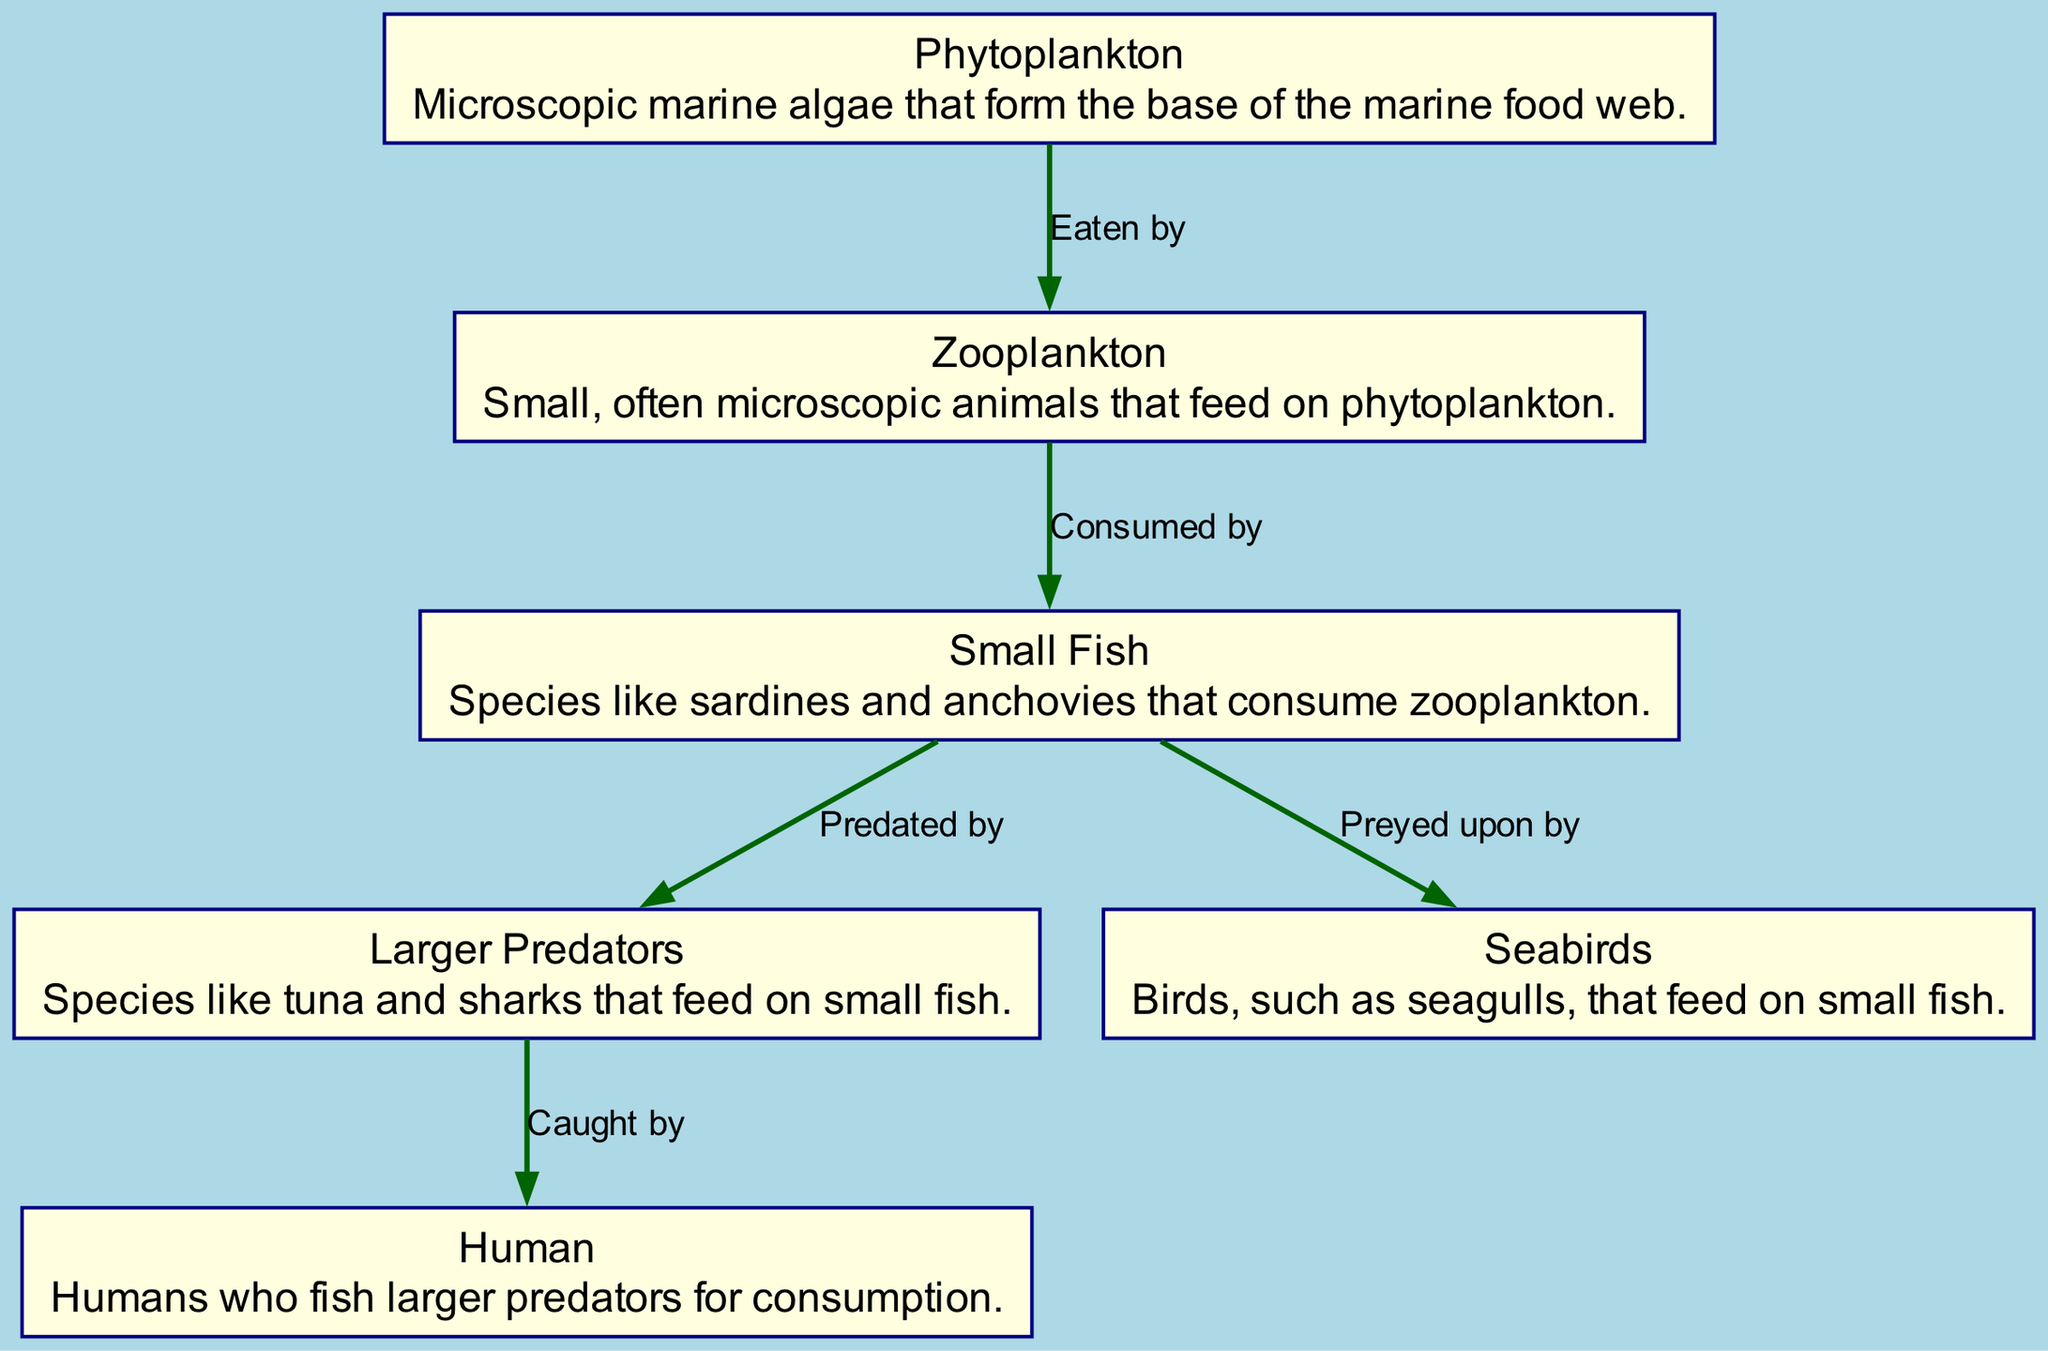What is the base of the marine food web? The diagram indicates that Phytoplankton forms the base of the marine food web, as it is the first node in the flow and is consumed by Zooplankton.
Answer: Phytoplankton How many nodes are present in the diagram? By counting all the distinct entries in the "nodes" section of the data, we find six nodes: Phytoplankton, Zooplankton, Small Fish, Larger Predators, Human, and Seabirds. This totals to six nodes.
Answer: 6 What do Zooplankton feed on? According to the diagram, Zooplankton is connected to Phytoplankton with an "Eaten by" relationship, which indicates that they feed on Phytoplankton.
Answer: Phytoplankton Which nodes prey on Small Fish? The diagram shows two edges leading from Small Fish: one to Larger Predators ("Predated by") and one to Seabirds ("Preyed upon by"). Therefore, both Larger Predators and Seabirds prey on Small Fish.
Answer: Larger Predators, Seabirds Who catches Larger Predators according to the diagram? The diagram shows an edge connecting Larger Predators to Humans labeled "Caught by," which indicates that Humans catch Larger Predators for consumption.
Answer: Human What is the relationship between Small Fish and Zooplankton? The diagram establishes that Small Fish consume Zooplankton, as indicated by the edge labeled "Consumed by" from Zooplankton to Small Fish.
Answer: Consumed by Which element of the food web is consumed by humans? The diagram shows a direct edge from Larger Predators to Humans labeled "Caught by," signifying that Humans consume Larger Predators.
Answer: Larger Predators How many edges connect the nodes in the diagram? By counting each connection between nodes in the "edges" section, we find five edges: one each from Phytoplankton to Zooplankton, from Zooplankton to Small Fish, from Small Fish to Larger Predators, from Larger Predators to Human, and from Small Fish to Seabirds. Thus, there are five edges.
Answer: 5 